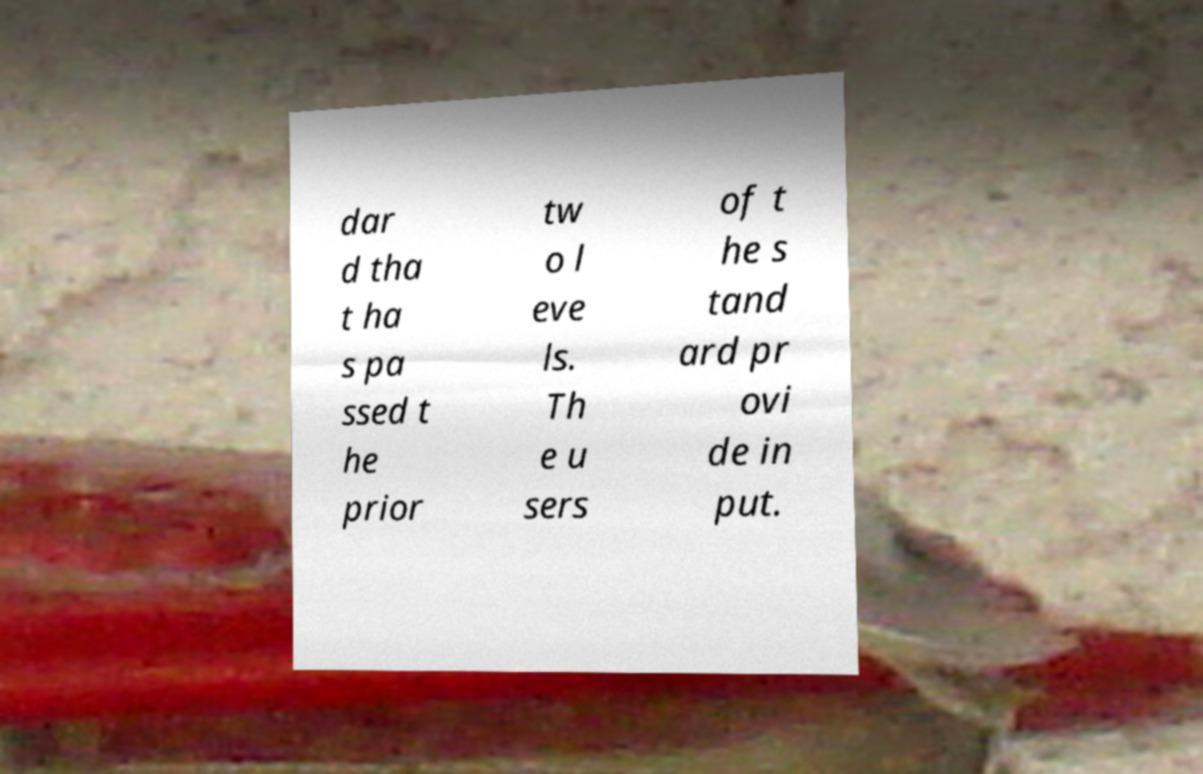Please read and relay the text visible in this image. What does it say? dar d tha t ha s pa ssed t he prior tw o l eve ls. Th e u sers of t he s tand ard pr ovi de in put. 